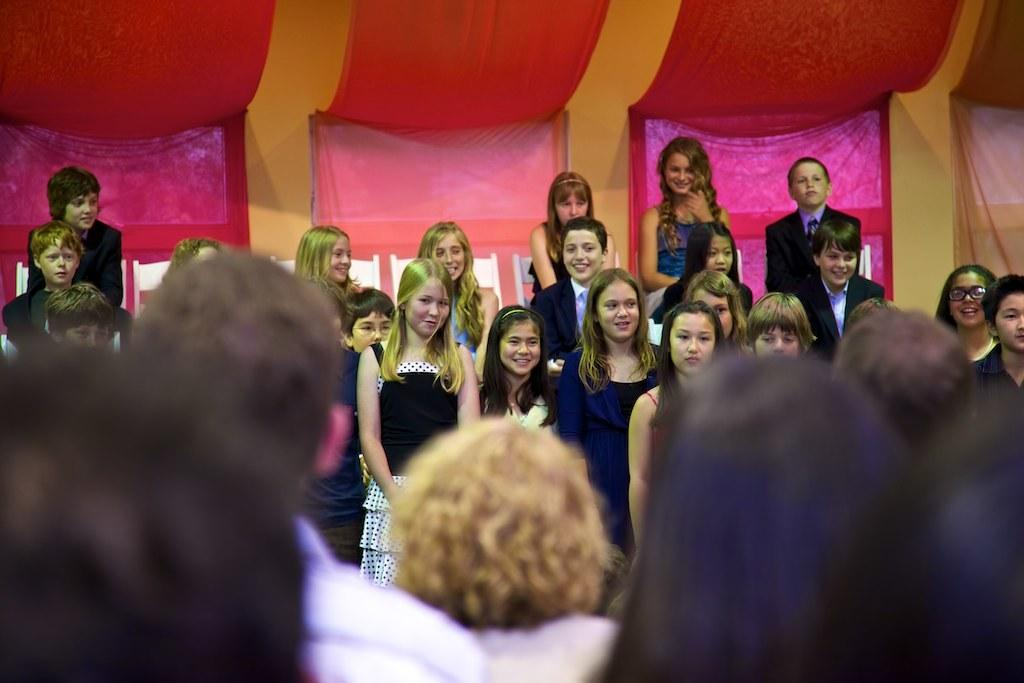How many people are present in the image? There are many people standing in the image. What are the people wearing? The people are wearing clothes. What is the facial expression of the people in the image? The people are smiling. Can you describe any decorative elements in the image? There is a decorative cloth in the image. Is there any part of the image that is not in focus? Yes, a part of the image is blurred. What type of comb is being used by the people in the image? There is no comb visible in the image; the people are simply standing and smiling. 